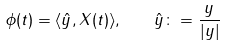Convert formula to latex. <formula><loc_0><loc_0><loc_500><loc_500>\phi ( t ) = \langle \hat { y } , X ( t ) \rangle , \quad \hat { y } \colon = \frac { y } { | y | }</formula> 